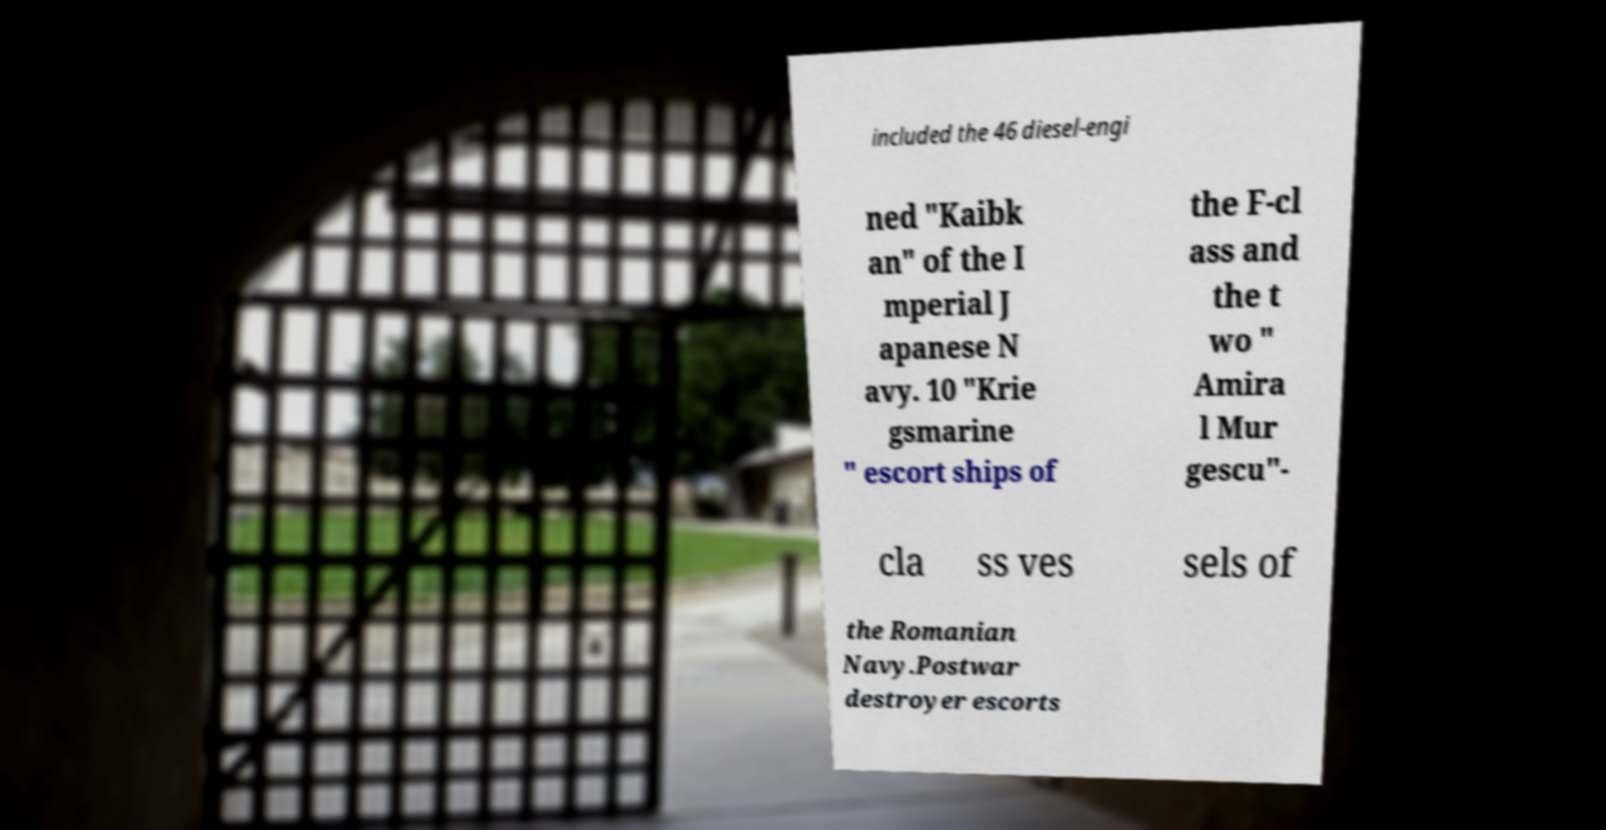Can you read and provide the text displayed in the image?This photo seems to have some interesting text. Can you extract and type it out for me? included the 46 diesel-engi ned "Kaibk an" of the I mperial J apanese N avy. 10 "Krie gsmarine " escort ships of the F-cl ass and the t wo " Amira l Mur gescu"- cla ss ves sels of the Romanian Navy.Postwar destroyer escorts 